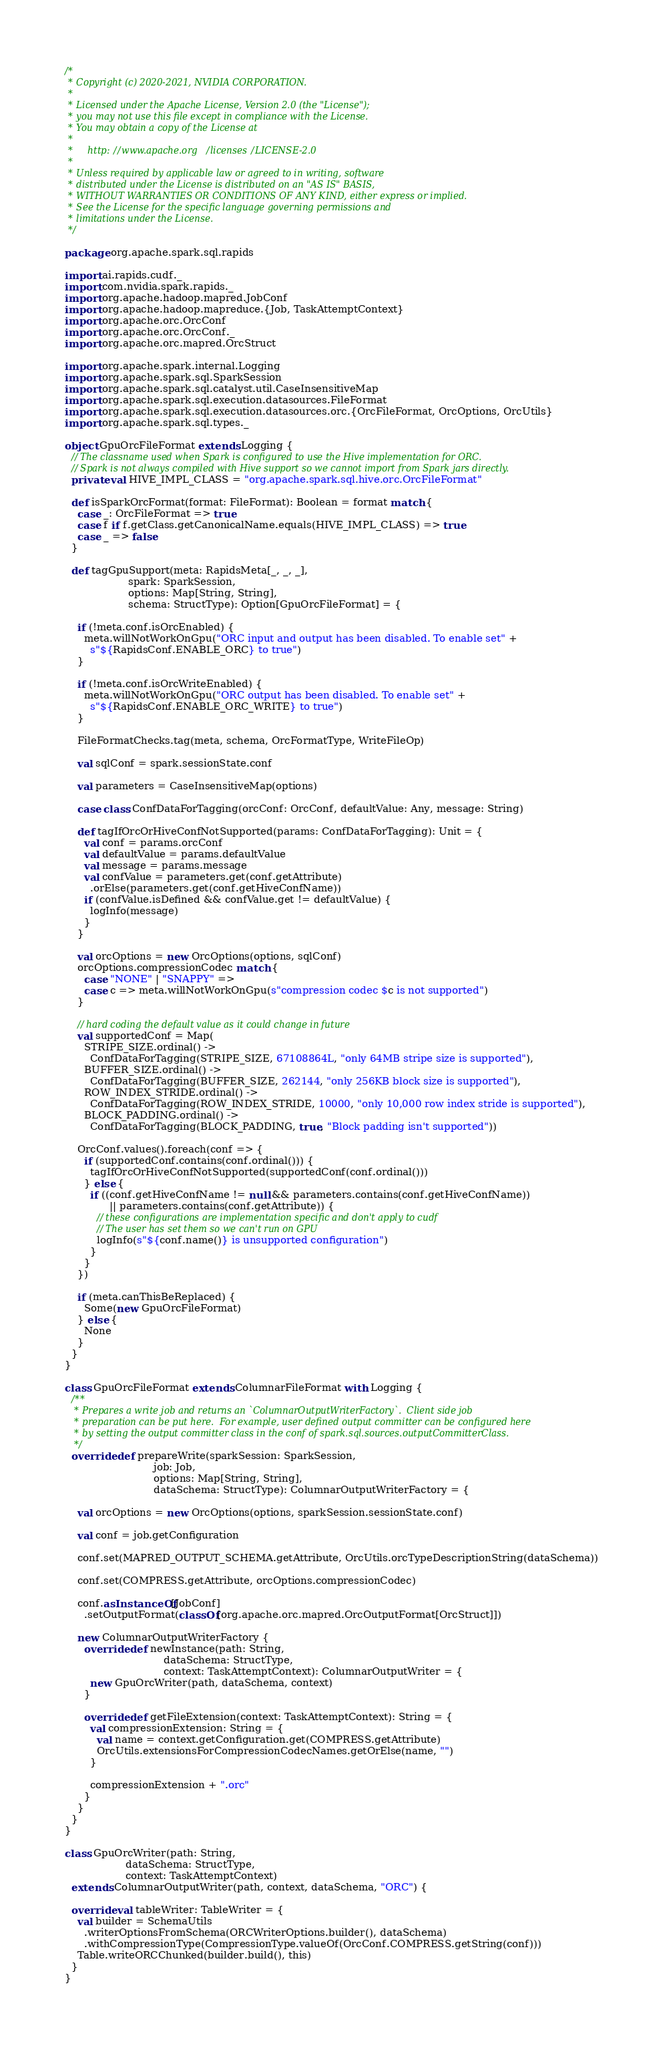Convert code to text. <code><loc_0><loc_0><loc_500><loc_500><_Scala_>/*
 * Copyright (c) 2020-2021, NVIDIA CORPORATION.
 *
 * Licensed under the Apache License, Version 2.0 (the "License");
 * you may not use this file except in compliance with the License.
 * You may obtain a copy of the License at
 *
 *     http://www.apache.org/licenses/LICENSE-2.0
 *
 * Unless required by applicable law or agreed to in writing, software
 * distributed under the License is distributed on an "AS IS" BASIS,
 * WITHOUT WARRANTIES OR CONDITIONS OF ANY KIND, either express or implied.
 * See the License for the specific language governing permissions and
 * limitations under the License.
 */

package org.apache.spark.sql.rapids

import ai.rapids.cudf._
import com.nvidia.spark.rapids._
import org.apache.hadoop.mapred.JobConf
import org.apache.hadoop.mapreduce.{Job, TaskAttemptContext}
import org.apache.orc.OrcConf
import org.apache.orc.OrcConf._
import org.apache.orc.mapred.OrcStruct

import org.apache.spark.internal.Logging
import org.apache.spark.sql.SparkSession
import org.apache.spark.sql.catalyst.util.CaseInsensitiveMap
import org.apache.spark.sql.execution.datasources.FileFormat
import org.apache.spark.sql.execution.datasources.orc.{OrcFileFormat, OrcOptions, OrcUtils}
import org.apache.spark.sql.types._

object GpuOrcFileFormat extends Logging {
  // The classname used when Spark is configured to use the Hive implementation for ORC.
  // Spark is not always compiled with Hive support so we cannot import from Spark jars directly.
  private val HIVE_IMPL_CLASS = "org.apache.spark.sql.hive.orc.OrcFileFormat"

  def isSparkOrcFormat(format: FileFormat): Boolean = format match {
    case _: OrcFileFormat => true
    case f if f.getClass.getCanonicalName.equals(HIVE_IMPL_CLASS) => true
    case _ => false
  }

  def tagGpuSupport(meta: RapidsMeta[_, _, _],
                    spark: SparkSession,
                    options: Map[String, String],
                    schema: StructType): Option[GpuOrcFileFormat] = {

    if (!meta.conf.isOrcEnabled) {
      meta.willNotWorkOnGpu("ORC input and output has been disabled. To enable set" +
        s"${RapidsConf.ENABLE_ORC} to true")
    }

    if (!meta.conf.isOrcWriteEnabled) {
      meta.willNotWorkOnGpu("ORC output has been disabled. To enable set" +
        s"${RapidsConf.ENABLE_ORC_WRITE} to true")
    }

    FileFormatChecks.tag(meta, schema, OrcFormatType, WriteFileOp)

    val sqlConf = spark.sessionState.conf

    val parameters = CaseInsensitiveMap(options)

    case class ConfDataForTagging(orcConf: OrcConf, defaultValue: Any, message: String)

    def tagIfOrcOrHiveConfNotSupported(params: ConfDataForTagging): Unit = {
      val conf = params.orcConf
      val defaultValue = params.defaultValue
      val message = params.message
      val confValue = parameters.get(conf.getAttribute)
        .orElse(parameters.get(conf.getHiveConfName))
      if (confValue.isDefined && confValue.get != defaultValue) {
        logInfo(message)
      }
    }

    val orcOptions = new OrcOptions(options, sqlConf)
    orcOptions.compressionCodec match {
      case "NONE" | "SNAPPY" =>
      case c => meta.willNotWorkOnGpu(s"compression codec $c is not supported")
    }

    // hard coding the default value as it could change in future
    val supportedConf = Map(
      STRIPE_SIZE.ordinal() ->
        ConfDataForTagging(STRIPE_SIZE, 67108864L, "only 64MB stripe size is supported"),
      BUFFER_SIZE.ordinal() ->
        ConfDataForTagging(BUFFER_SIZE, 262144, "only 256KB block size is supported"),
      ROW_INDEX_STRIDE.ordinal() ->
        ConfDataForTagging(ROW_INDEX_STRIDE, 10000, "only 10,000 row index stride is supported"),
      BLOCK_PADDING.ordinal() ->
        ConfDataForTagging(BLOCK_PADDING, true, "Block padding isn't supported"))

    OrcConf.values().foreach(conf => {
      if (supportedConf.contains(conf.ordinal())) {
        tagIfOrcOrHiveConfNotSupported(supportedConf(conf.ordinal()))
      } else {
        if ((conf.getHiveConfName != null && parameters.contains(conf.getHiveConfName))
              || parameters.contains(conf.getAttribute)) {
          // these configurations are implementation specific and don't apply to cudf
          // The user has set them so we can't run on GPU
          logInfo(s"${conf.name()} is unsupported configuration")
        }
      }
    })

    if (meta.canThisBeReplaced) {
      Some(new GpuOrcFileFormat)
    } else {
      None
    }
  }
}

class GpuOrcFileFormat extends ColumnarFileFormat with Logging {
  /**
   * Prepares a write job and returns an `ColumnarOutputWriterFactory`.  Client side job
   * preparation can be put here.  For example, user defined output committer can be configured here
   * by setting the output committer class in the conf of spark.sql.sources.outputCommitterClass.
   */
  override def prepareWrite(sparkSession: SparkSession,
                            job: Job,
                            options: Map[String, String],
                            dataSchema: StructType): ColumnarOutputWriterFactory = {

    val orcOptions = new OrcOptions(options, sparkSession.sessionState.conf)

    val conf = job.getConfiguration

    conf.set(MAPRED_OUTPUT_SCHEMA.getAttribute, OrcUtils.orcTypeDescriptionString(dataSchema))

    conf.set(COMPRESS.getAttribute, orcOptions.compressionCodec)

    conf.asInstanceOf[JobConf]
      .setOutputFormat(classOf[org.apache.orc.mapred.OrcOutputFormat[OrcStruct]])

    new ColumnarOutputWriterFactory {
      override def newInstance(path: String,
                               dataSchema: StructType,
                               context: TaskAttemptContext): ColumnarOutputWriter = {
        new GpuOrcWriter(path, dataSchema, context)
      }

      override def getFileExtension(context: TaskAttemptContext): String = {
        val compressionExtension: String = {
          val name = context.getConfiguration.get(COMPRESS.getAttribute)
          OrcUtils.extensionsForCompressionCodecNames.getOrElse(name, "")
        }

        compressionExtension + ".orc"
      }
    }
  }
}

class GpuOrcWriter(path: String,
                   dataSchema: StructType,
                   context: TaskAttemptContext)
  extends ColumnarOutputWriter(path, context, dataSchema, "ORC") {

  override val tableWriter: TableWriter = {
    val builder = SchemaUtils
      .writerOptionsFromSchema(ORCWriterOptions.builder(), dataSchema)
      .withCompressionType(CompressionType.valueOf(OrcConf.COMPRESS.getString(conf)))
    Table.writeORCChunked(builder.build(), this)
  }
}
</code> 